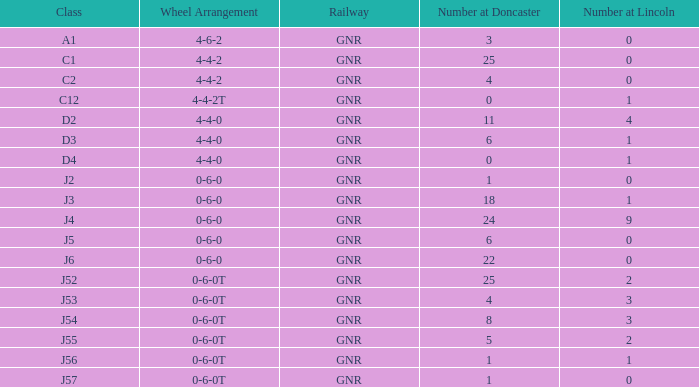Which class holds a number at lincoln below 1 and a wheel formation of 0-6-0? J2, J5, J6. 